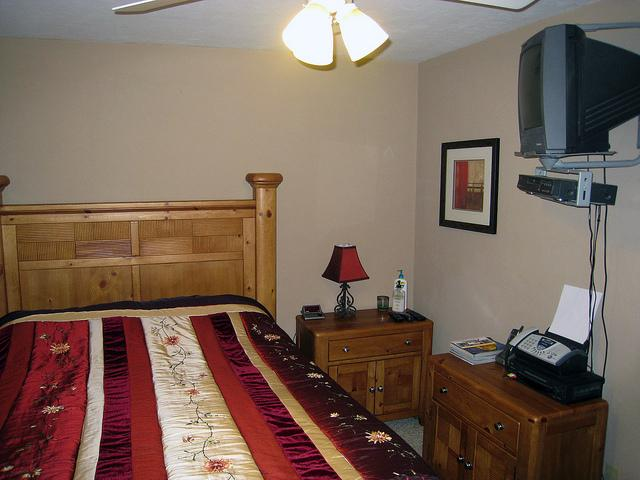What color is the main stripe on the right side of the queen sized bed? red 